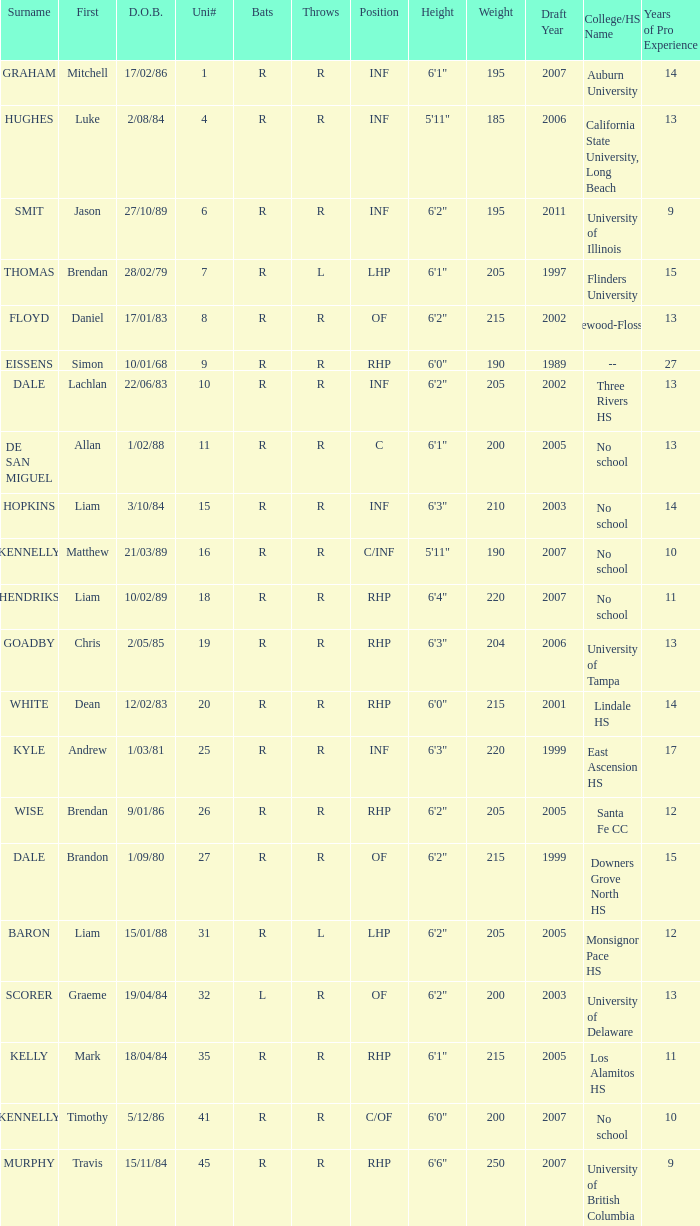Which batter has a uni# of 31? R. 